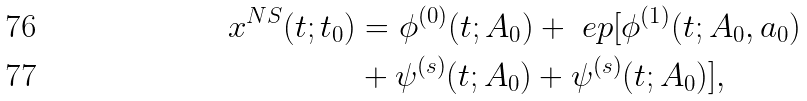Convert formula to latex. <formula><loc_0><loc_0><loc_500><loc_500>x ^ { N S } ( t ; t _ { 0 } ) & = \phi ^ { ( 0 ) } ( t ; A _ { 0 } ) + \ e p [ \phi ^ { ( 1 ) } ( t ; A _ { 0 } , a _ { 0 } ) \\ & + \psi ^ { ( s ) } ( t ; A _ { 0 } ) + \psi ^ { ( s ) } ( t ; A _ { 0 } ) ] ,</formula> 